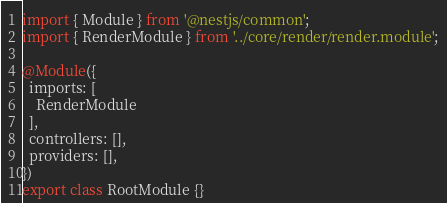Convert code to text. <code><loc_0><loc_0><loc_500><loc_500><_TypeScript_>import { Module } from '@nestjs/common';
import { RenderModule } from '../core/render/render.module';

@Module({
  imports: [
    RenderModule
  ],
  controllers: [],
  providers: [],
})
export class RootModule {}
</code> 